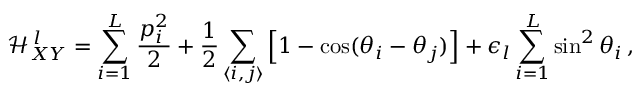Convert formula to latex. <formula><loc_0><loc_0><loc_500><loc_500>\mathcal { H } _ { X Y } ^ { \, l } = \sum _ { i = 1 } ^ { L } \frac { p _ { i } ^ { 2 } } { 2 } + \frac { 1 } { 2 } \sum _ { \langle i , j \rangle } \left [ 1 - \cos ( \theta _ { i } - \theta _ { j } ) \right ] + \epsilon _ { l } \sum _ { i = 1 } ^ { L } \sin ^ { 2 } { \theta _ { i } } \, ,</formula> 